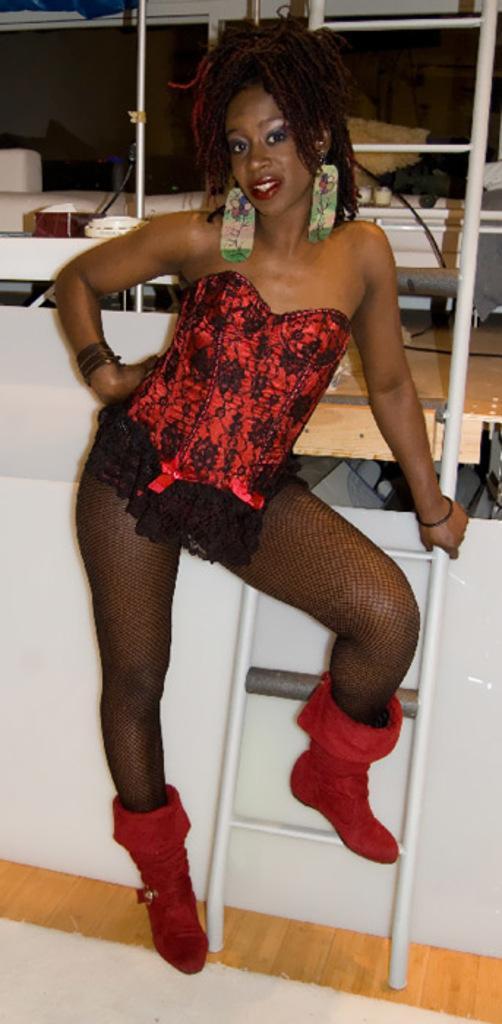In one or two sentences, can you explain what this image depicts? Here in this picture we can see a woman in a black and red colored dress standing on the place over there and behind her we can see a ladder present and we can see red colored boots on her and she is smiling. 